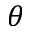<formula> <loc_0><loc_0><loc_500><loc_500>\theta</formula> 